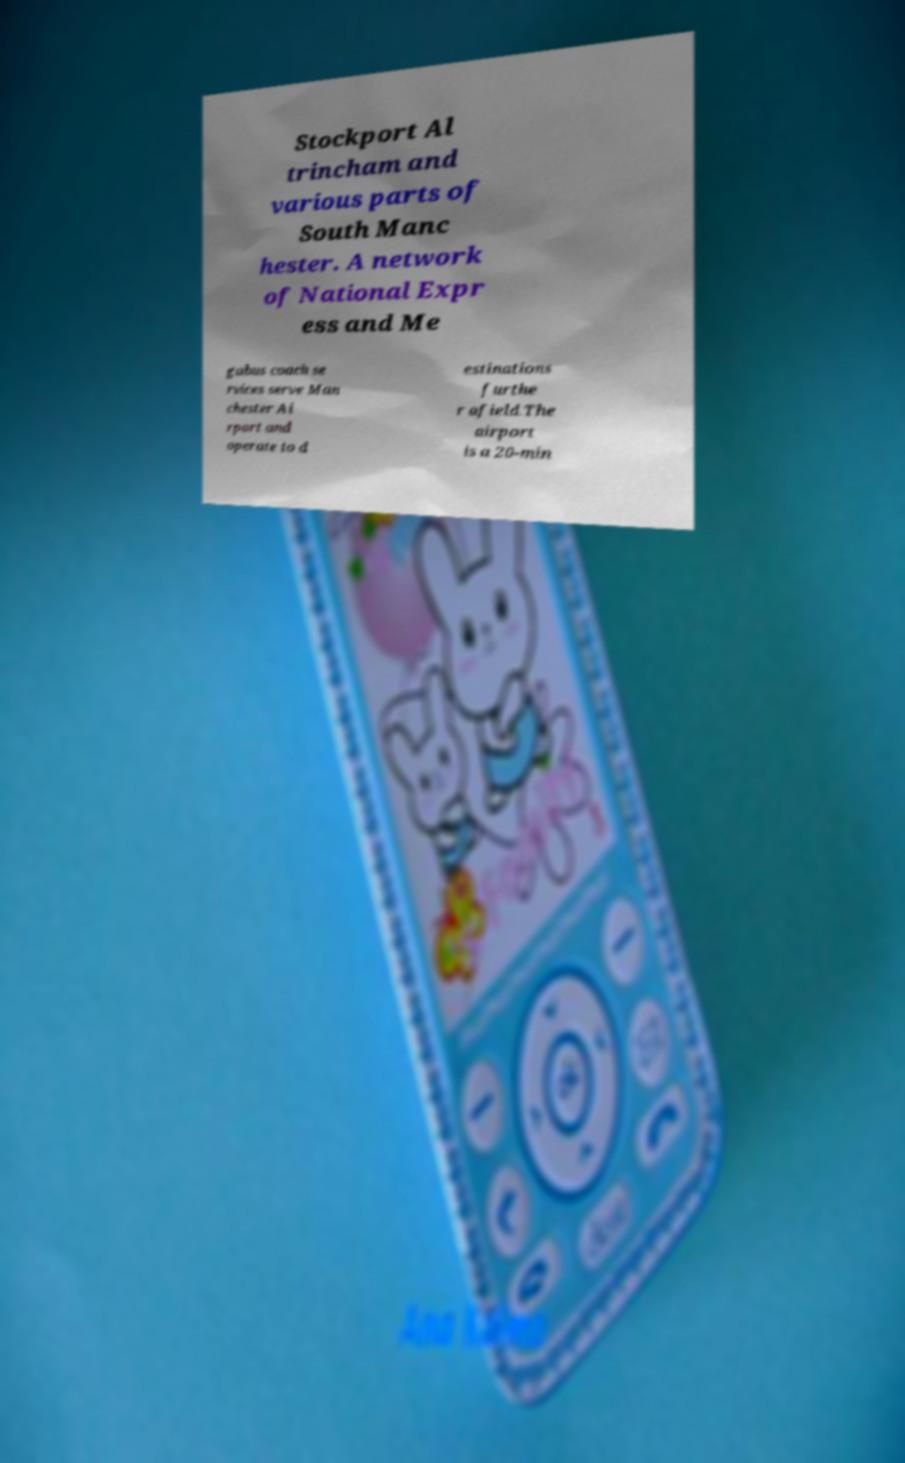Please read and relay the text visible in this image. What does it say? Stockport Al trincham and various parts of South Manc hester. A network of National Expr ess and Me gabus coach se rvices serve Man chester Ai rport and operate to d estinations furthe r afield.The airport is a 20-min 